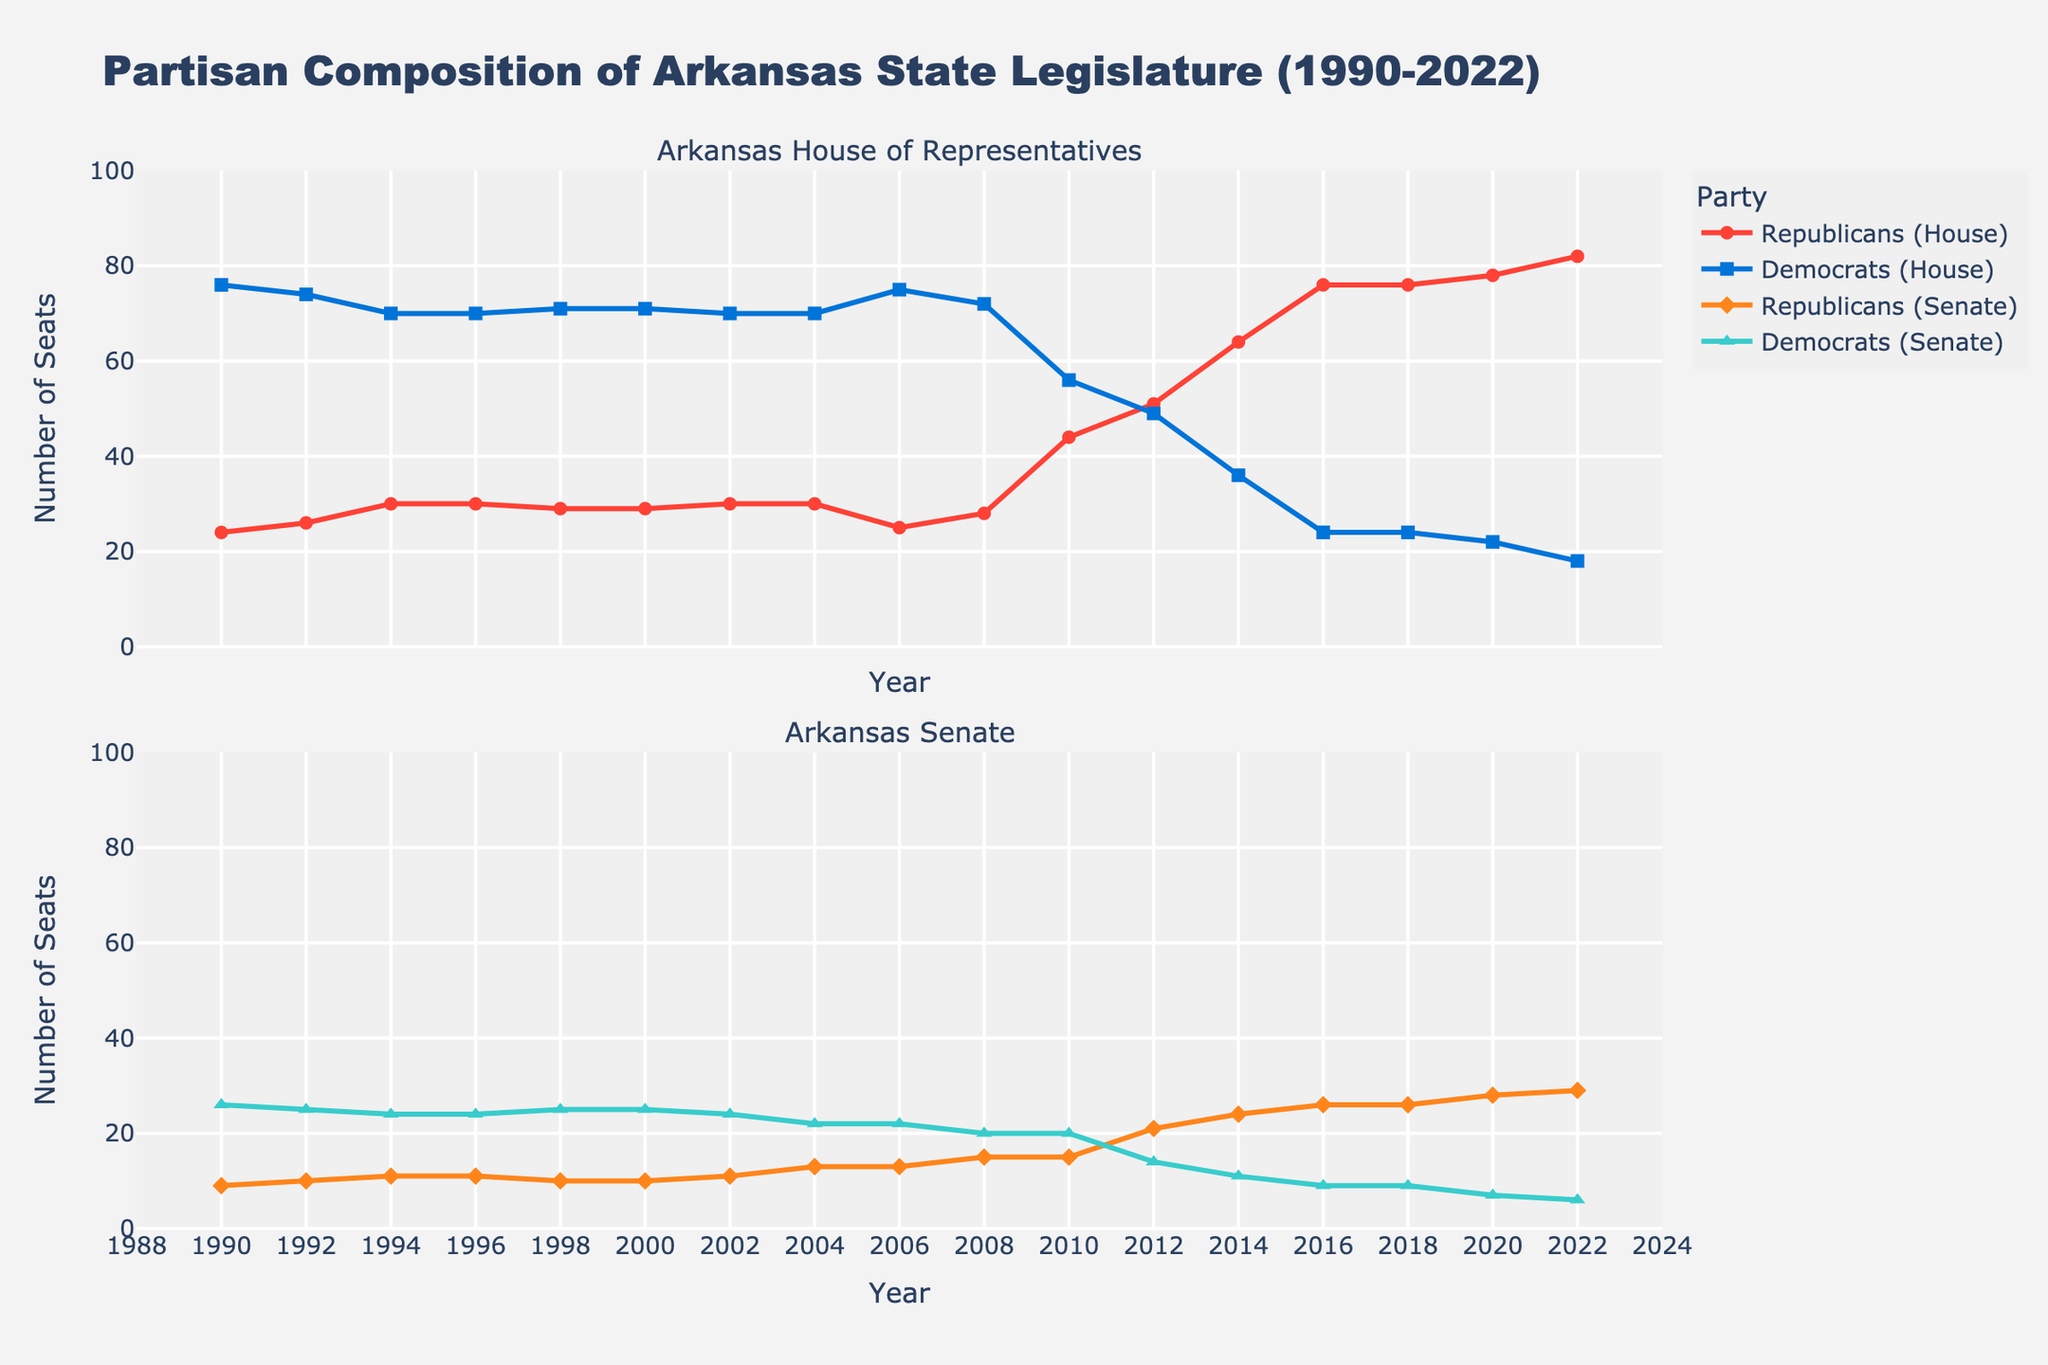What is the total number of seats in the Arkansas House of Representatives in 1990? In 1990, the chart shows that Republicans held 24 seats and Democrats held 76 seats in the House. Adding these together gives 24 + 76 = 100.
Answer: 100 In which year did Republicans in the Arkansas Senate exceed 20 seats for the first time? The chart shows that Republicans in the Senate first reached 21 seats in 2012.
Answer: 2012 How did the composition of the Arkansas House of Representatives change from 2010 to 2012 for Republicans and Democrats? In 2010, Republicans had 44 seats and Democrats had 56 seats. By 2012, Republicans increased to 51 seats and Democrats decreased to 49 seats. Republicans gained 7 seats, and Democrats lost 7 seats.
Answer: Republicans gained 7 seats, Democrats lost 7 seats What is the difference in the number of Republican seats between the Arkansas House of Representatives and Senate in 2020? In 2020, the chart shows Republicans held 78 House seats and 28 Senate seats. The difference is 78 - 28 = 50 seats.
Answer: 50 seats Describe the overall trend in the number of Democrat seats in both the Arkansas House and Senate from 1990 to 2022. The chart shows a clear declining trend in Democrat seats in both the House and Senate from 1990 to 2022. In the House, seats drop from 76 to 18, and in the Senate, seats drop from 26 to 6.
Answer: Declining trend How does the 2014 composition for the Arkansas House of Representatives compare to that of 1994? In 1994, Republicans held 30 seats and Democrats had 70 seats in the House. In 2014, Republicans held 64 seats and Democrats had 36 seats. The composition shifted dramatically in favor of Republicans over the 20-year period.
Answer: Shifted towards Republicans How many total seats did Democrats lose in both the Arkansas House and Senate from 2000 to 2004? In the House, Democrats went from 71 seats in 2000 to 70 seats in 2004, losing 1 seat. In the Senate, Democrats went from 25 seats in 2000 to 22 seats in 2004, losing 3 seats. In total, Democrats lost 1 + 3 = 4 seats.
Answer: 4 seats Which party held the majority in both the Arkansas House and Senate in 2006? In 2006, Democrats held the majority in both the House (75 seats) and the Senate (22 seats).
Answer: Democrats By how many seats did the Republican representation in the Arkansas Senate increase from 2004 to 2022? In 2004, Republicans had 13 seats in the Senate. By 2022, this increased to 29 seats. The increase is 29 - 13 = 16 seats.
Answer: 16 seats How did the total number of seats (sum of House and Senate seats) for Republicans change from 1990 to 2022? In 1990, Republicans had 24 House and 9 Senate seats, for a total of 33 seats. In 2022, they had 82 House and 29 Senate seats, for a total of 111 seats. The change is 111 - 33 = 78 seats.
Answer: Increased by 78 seats 